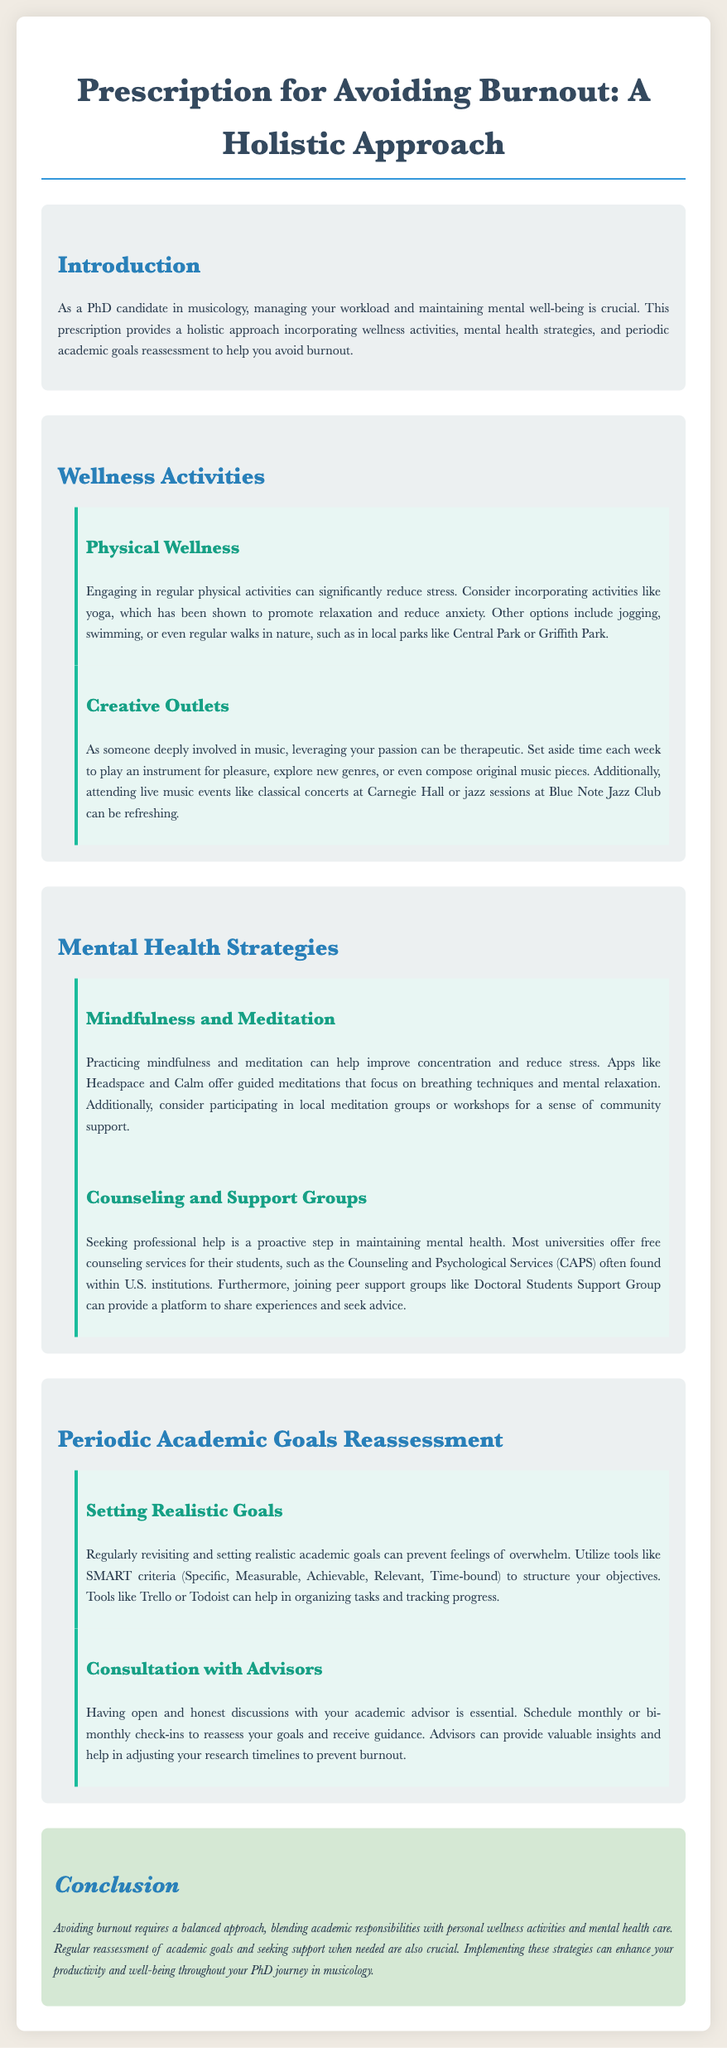What is the main focus of the prescription? The main focus of the prescription is a holistic approach to avoiding burnout by incorporating wellness activities, mental health strategies, and periodic academic goals reassessment.
Answer: holistic approach What are two examples of physical wellness activities mentioned? Two examples of physical wellness activities mentioned are yoga and jogging.
Answer: yoga, jogging What is one mental health strategy discussed in the document? One mental health strategy discussed is practicing mindfulness and meditation.
Answer: mindfulness and meditation What tool is suggested for setting realistic academic goals? The tool suggested for setting realistic academic goals is the SMART criteria.
Answer: SMART criteria How often should you schedule check-ins with your academic advisor? You should schedule check-ins with your academic advisor monthly or bi-monthly.
Answer: monthly or bi-monthly What type of support can peer groups provide? Peer groups can provide a platform to share experiences and seek advice.
Answer: share experiences and seek advice What is the purpose of counseling services mentioned in the document? The purpose of counseling services is to maintain mental health for students.
Answer: maintain mental health Which app is mentioned for mindfulness practice? The app mentioned for mindfulness practice is Headspace.
Answer: Headspace 